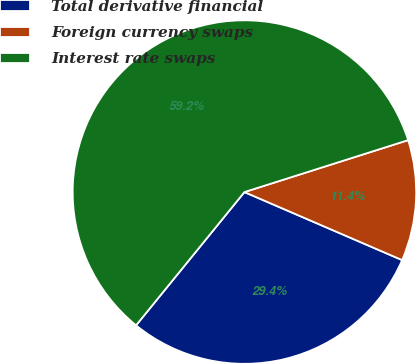Convert chart to OTSL. <chart><loc_0><loc_0><loc_500><loc_500><pie_chart><fcel>Total derivative financial<fcel>Foreign currency swaps<fcel>Interest rate swaps<nl><fcel>29.38%<fcel>11.37%<fcel>59.24%<nl></chart> 